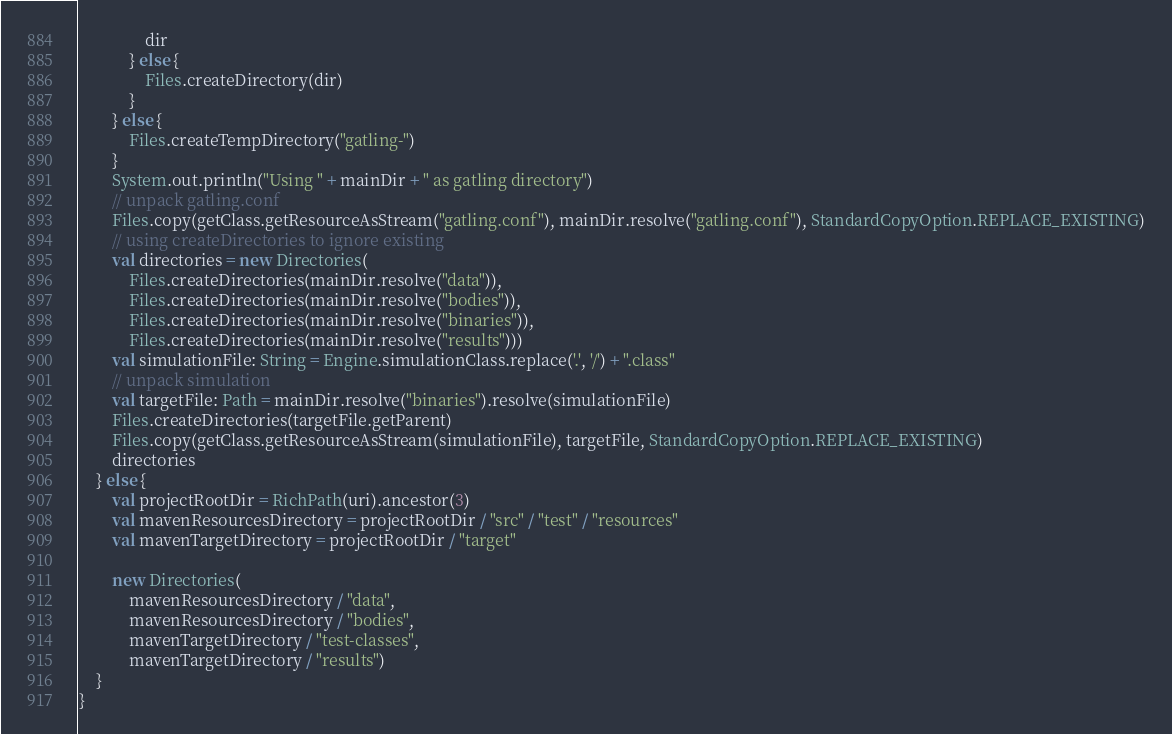Convert code to text. <code><loc_0><loc_0><loc_500><loc_500><_Scala_>				dir
			} else {
				Files.createDirectory(dir)
			}
		} else {
			Files.createTempDirectory("gatling-")
		}
		System.out.println("Using " + mainDir + " as gatling directory")
		// unpack gatling.conf
		Files.copy(getClass.getResourceAsStream("gatling.conf"), mainDir.resolve("gatling.conf"), StandardCopyOption.REPLACE_EXISTING)
		// using createDirectories to ignore existing
		val directories = new Directories(
			Files.createDirectories(mainDir.resolve("data")),
			Files.createDirectories(mainDir.resolve("bodies")),
			Files.createDirectories(mainDir.resolve("binaries")),
			Files.createDirectories(mainDir.resolve("results")))
		val simulationFile: String = Engine.simulationClass.replace('.', '/') + ".class"
		// unpack simulation
		val targetFile: Path = mainDir.resolve("binaries").resolve(simulationFile)
		Files.createDirectories(targetFile.getParent)
		Files.copy(getClass.getResourceAsStream(simulationFile), targetFile, StandardCopyOption.REPLACE_EXISTING)
		directories
	} else {
		val projectRootDir = RichPath(uri).ancestor(3)
		val mavenResourcesDirectory = projectRootDir / "src" / "test" / "resources"
		val mavenTargetDirectory = projectRootDir / "target"

		new Directories(
			mavenResourcesDirectory / "data",
			mavenResourcesDirectory / "bodies",
			mavenTargetDirectory / "test-classes",
			mavenTargetDirectory / "results")
	}
}
</code> 